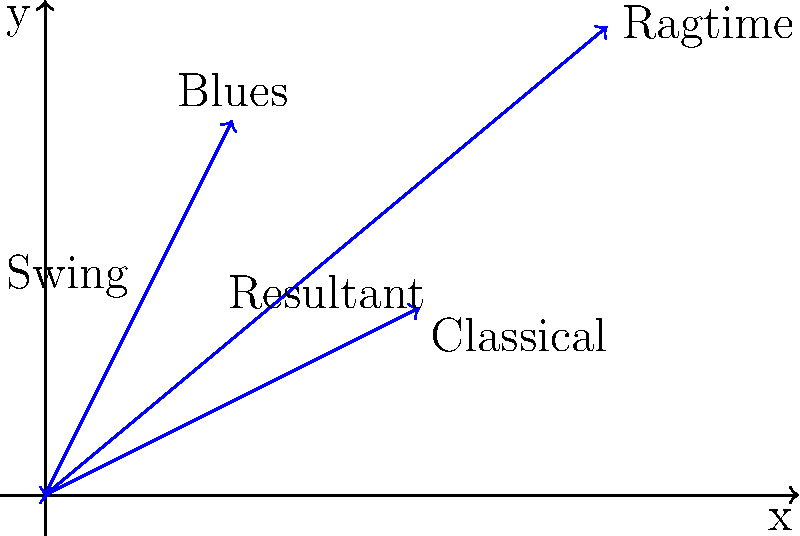Duke Ellington's unique jazz style was influenced by various musical genres. The vectors in the diagram represent the magnitude and direction of influence from Swing, Blues, Classical, and Ragtime on his music. If we consider these influences as force vectors, what is the magnitude of the resultant vector (rounded to the nearest whole number) representing Duke Ellington's overall musical style? To find the magnitude of the resultant vector, we need to follow these steps:

1. Identify the components of each vector:
   Swing: (2, 4)
   Blues: (4, 2)
   Classical: (2, 0)
   Ragtime: (6, 5)

2. Sum the x-components and y-components separately:
   x_total = 2 + 4 + 2 + 6 = 14
   y_total = 4 + 2 + 0 + 5 = 11

3. The resultant vector is (14, 11)

4. Calculate the magnitude using the Pythagorean theorem:
   $$|\vec{R}| = \sqrt{x^2 + y^2} = \sqrt{14^2 + 11^2}$$

5. Solve:
   $$|\vec{R}| = \sqrt{196 + 121} = \sqrt{317} \approx 17.8$$

6. Round to the nearest whole number:
   18

Therefore, the magnitude of the resultant vector representing Duke Ellington's overall musical style is approximately 18 units.
Answer: 18 